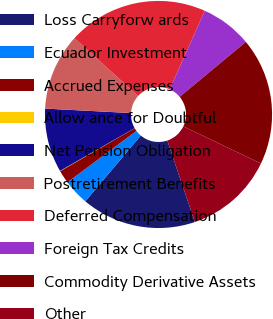<chart> <loc_0><loc_0><loc_500><loc_500><pie_chart><fcel>Loss Carryforw ards<fcel>Ecuador Investment<fcel>Accrued Expenses<fcel>Allow ance for Doubtful<fcel>Net Pension Obligation<fcel>Postretirement Benefits<fcel>Deferred Compensation<fcel>Foreign Tax Credits<fcel>Commodity Derivative Assets<fcel>Other<nl><fcel>16.33%<fcel>3.67%<fcel>1.86%<fcel>0.05%<fcel>9.1%<fcel>10.9%<fcel>19.95%<fcel>7.29%<fcel>18.14%<fcel>12.71%<nl></chart> 